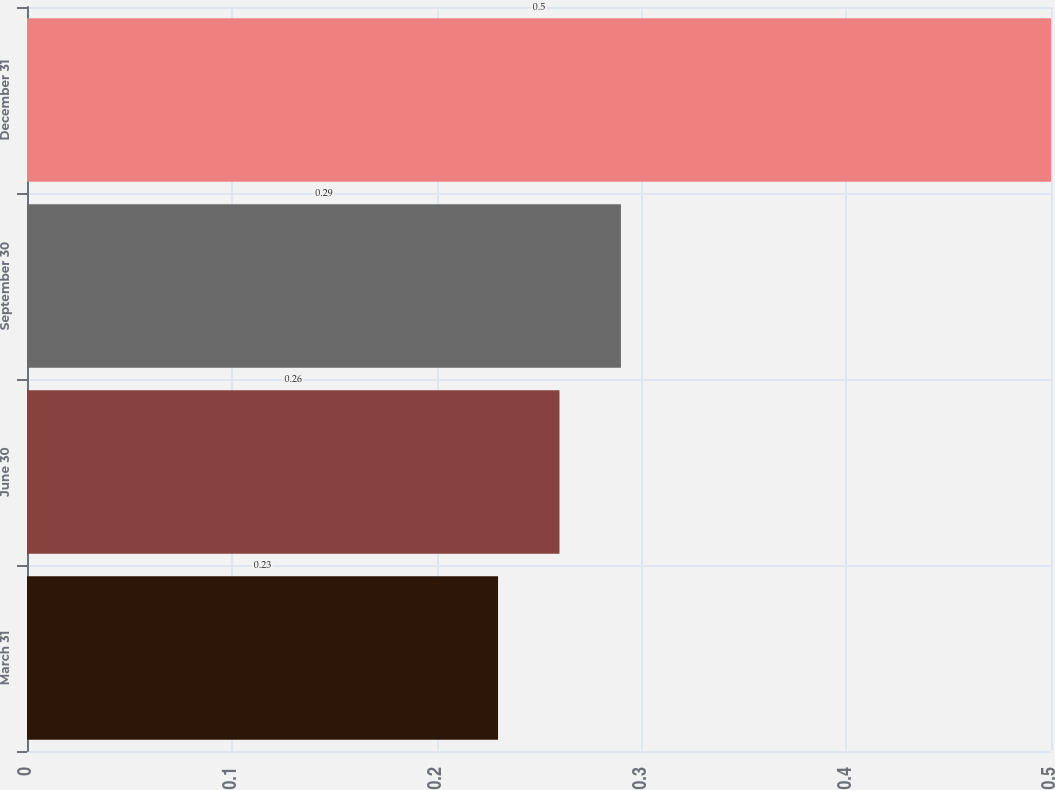Convert chart to OTSL. <chart><loc_0><loc_0><loc_500><loc_500><bar_chart><fcel>March 31<fcel>June 30<fcel>September 30<fcel>December 31<nl><fcel>0.23<fcel>0.26<fcel>0.29<fcel>0.5<nl></chart> 